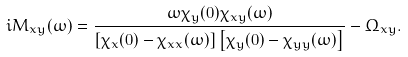Convert formula to latex. <formula><loc_0><loc_0><loc_500><loc_500>i M _ { x y } ( \omega ) = \frac { \omega \chi _ { y } ( 0 ) \chi _ { x y } ( \omega ) } { \left [ \chi _ { x } ( 0 ) - \chi _ { x x } ( \omega ) \right ] \left [ \chi _ { y } ( 0 ) - \chi _ { y y } ( \omega ) \right ] } - \Omega _ { x y } .</formula> 